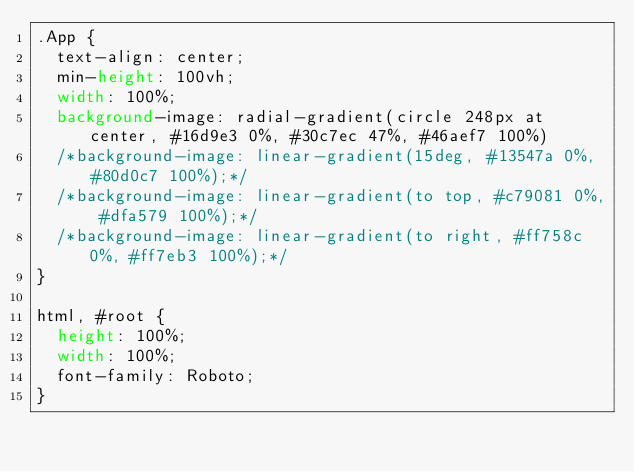<code> <loc_0><loc_0><loc_500><loc_500><_CSS_>.App {
  text-align: center;
  min-height: 100vh;
  width: 100%;
  background-image: radial-gradient(circle 248px at center, #16d9e3 0%, #30c7ec 47%, #46aef7 100%)
  /*background-image: linear-gradient(15deg, #13547a 0%, #80d0c7 100%);*/
  /*background-image: linear-gradient(to top, #c79081 0%, #dfa579 100%);*/
  /*background-image: linear-gradient(to right, #ff758c 0%, #ff7eb3 100%);*/
}

html, #root {
  height: 100%;
  width: 100%;
  font-family: Roboto;
}
</code> 